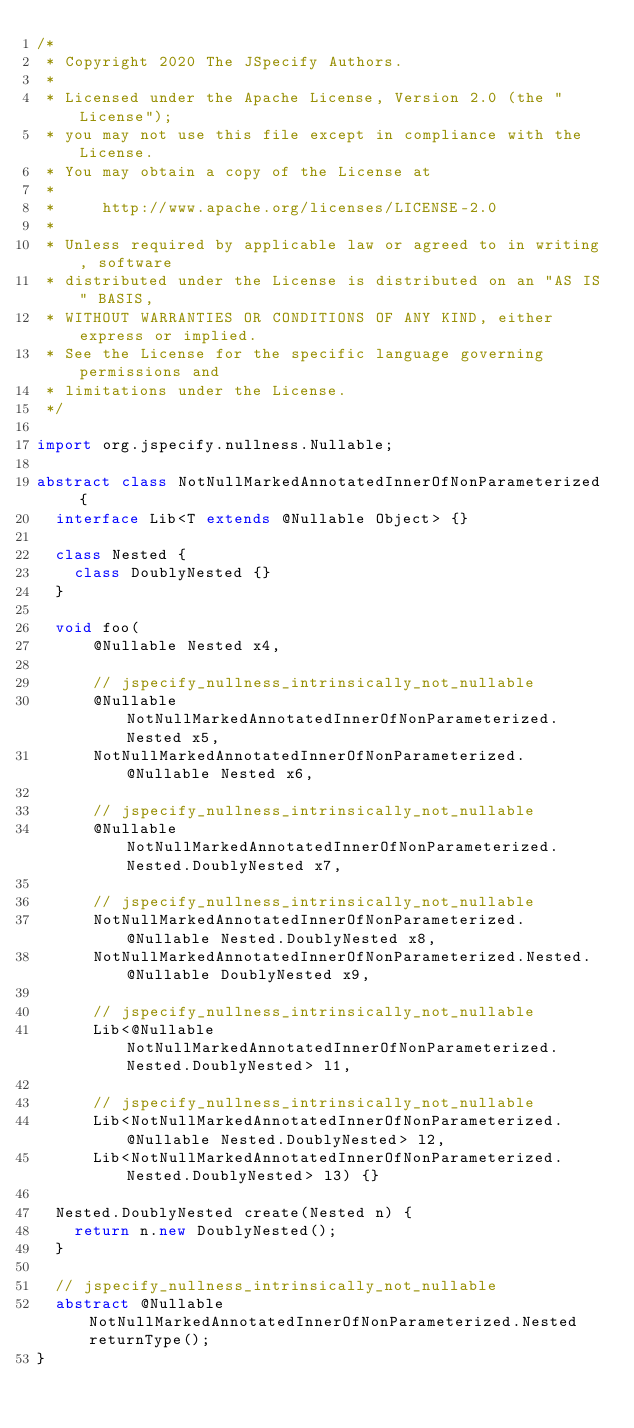<code> <loc_0><loc_0><loc_500><loc_500><_Java_>/*
 * Copyright 2020 The JSpecify Authors.
 *
 * Licensed under the Apache License, Version 2.0 (the "License");
 * you may not use this file except in compliance with the License.
 * You may obtain a copy of the License at
 *
 *     http://www.apache.org/licenses/LICENSE-2.0
 *
 * Unless required by applicable law or agreed to in writing, software
 * distributed under the License is distributed on an "AS IS" BASIS,
 * WITHOUT WARRANTIES OR CONDITIONS OF ANY KIND, either express or implied.
 * See the License for the specific language governing permissions and
 * limitations under the License.
 */

import org.jspecify.nullness.Nullable;

abstract class NotNullMarkedAnnotatedInnerOfNonParameterized {
  interface Lib<T extends @Nullable Object> {}

  class Nested {
    class DoublyNested {}
  }

  void foo(
      @Nullable Nested x4,

      // jspecify_nullness_intrinsically_not_nullable
      @Nullable NotNullMarkedAnnotatedInnerOfNonParameterized.Nested x5,
      NotNullMarkedAnnotatedInnerOfNonParameterized.@Nullable Nested x6,

      // jspecify_nullness_intrinsically_not_nullable
      @Nullable NotNullMarkedAnnotatedInnerOfNonParameterized.Nested.DoublyNested x7,

      // jspecify_nullness_intrinsically_not_nullable
      NotNullMarkedAnnotatedInnerOfNonParameterized.@Nullable Nested.DoublyNested x8,
      NotNullMarkedAnnotatedInnerOfNonParameterized.Nested.@Nullable DoublyNested x9,

      // jspecify_nullness_intrinsically_not_nullable
      Lib<@Nullable NotNullMarkedAnnotatedInnerOfNonParameterized.Nested.DoublyNested> l1,

      // jspecify_nullness_intrinsically_not_nullable
      Lib<NotNullMarkedAnnotatedInnerOfNonParameterized.@Nullable Nested.DoublyNested> l2,
      Lib<NotNullMarkedAnnotatedInnerOfNonParameterized.Nested.DoublyNested> l3) {}

  Nested.DoublyNested create(Nested n) {
    return n.new DoublyNested();
  }

  // jspecify_nullness_intrinsically_not_nullable
  abstract @Nullable NotNullMarkedAnnotatedInnerOfNonParameterized.Nested returnType();
}
</code> 